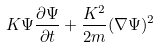<formula> <loc_0><loc_0><loc_500><loc_500>K \Psi \frac { \partial \Psi } { \partial t } + \frac { K ^ { 2 } } { 2 m } ( \nabla \Psi ) ^ { 2 }</formula> 